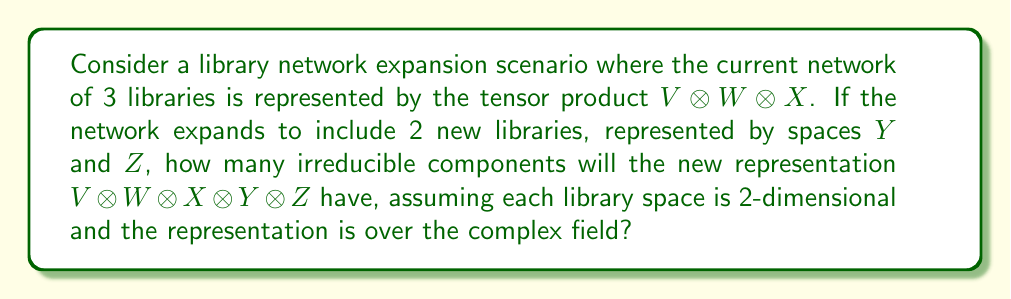Teach me how to tackle this problem. To solve this problem, we'll follow these steps:

1) First, recall that for 2-dimensional vector spaces over the complex field, we have:

   $V \otimes W \cong S^2(V \oplus W) \oplus \Lambda^2(V \oplus W)$

   where $S^2$ is the symmetric square and $\Lambda^2$ is the exterior square.

2) The dimension of $S^2(V \oplus W)$ is $\binom{4}{2} = 6$, and the dimension of $\Lambda^2(V \oplus W)$ is $\binom{4}{2} = 6$.

3) So, $V \otimes W$ decomposes into two 6-dimensional irreducible components.

4) Now, let's consider the tensor product of three spaces: $V \otimes W \otimes X$

   This will have $2 \times 2 = 4$ irreducible components, each of dimension 6.

5) Adding the fourth space $Y$, we get:

   $(V \otimes W \otimes X) \otimes Y$

   This will have $4 \times 2 = 8$ irreducible components.

6) Finally, adding the fifth space $Z$, we get:

   $((V \otimes W \otimes X) \otimes Y) \otimes Z$

   This will have $8 \times 2 = 16$ irreducible components.

Therefore, the final representation $V \otimes W \otimes X \otimes Y \otimes Z$ will have 16 irreducible components.

This analysis can be interpreted in the context of library networks as representing the increasing complexity and interconnectedness of the library system as it expands, which could have implications for economic development in the region.
Answer: 16 irreducible components 